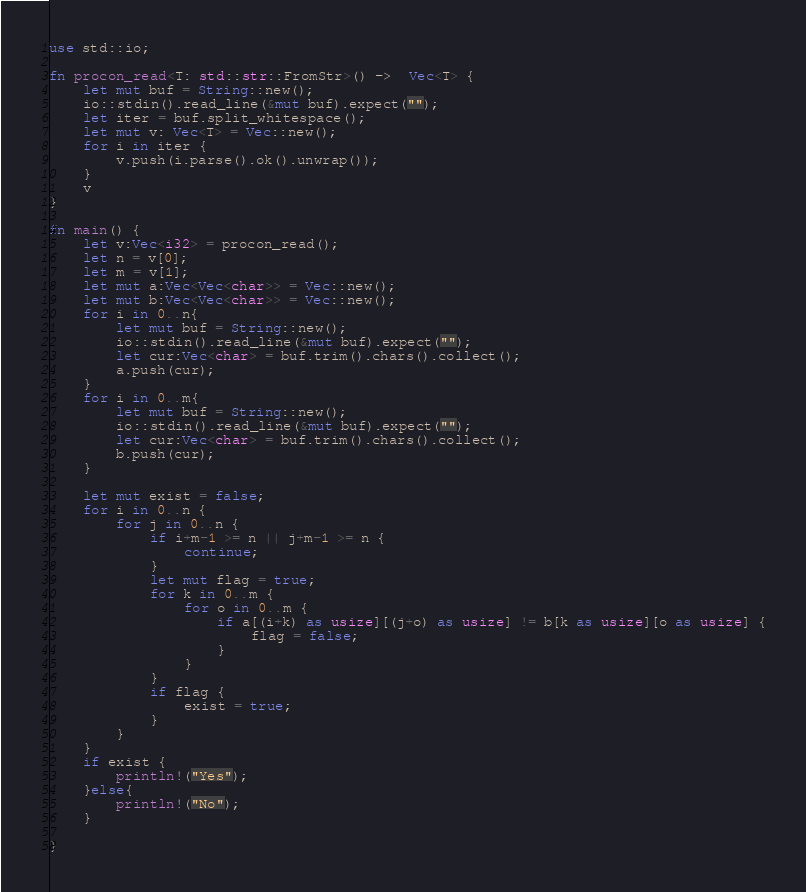Convert code to text. <code><loc_0><loc_0><loc_500><loc_500><_Rust_>use std::io;

fn procon_read<T: std::str::FromStr>() ->  Vec<T> {
	let mut buf = String::new();
	io::stdin().read_line(&mut buf).expect("");
	let iter = buf.split_whitespace();
	let mut v: Vec<T> = Vec::new();
	for i in iter {
		v.push(i.parse().ok().unwrap());
	}
	v
}

fn main() {
	let v:Vec<i32> = procon_read();
	let n = v[0];
	let m = v[1];
	let mut a:Vec<Vec<char>> = Vec::new();
	let mut b:Vec<Vec<char>> = Vec::new();
	for i in 0..n{
		let mut buf = String::new();
		io::stdin().read_line(&mut buf).expect("");
		let cur:Vec<char> = buf.trim().chars().collect();
		a.push(cur);
	}
	for i in 0..m{
		let mut buf = String::new();
		io::stdin().read_line(&mut buf).expect("");
		let cur:Vec<char> = buf.trim().chars().collect();
		b.push(cur);
	}
	
	let mut exist = false;
	for i in 0..n {
		for j in 0..n {
			if i+m-1 >= n || j+m-1 >= n {
				continue;
			}
			let mut flag = true;
			for k in 0..m {
				for o in 0..m {
					if a[(i+k) as usize][(j+o) as usize] != b[k as usize][o as usize] {
						flag = false;
					}
				}
			}
			if flag {
				exist = true;
			}
		}
	}
	if exist {
		println!("Yes");
	}else{
		println!("No");
	}
	
}</code> 